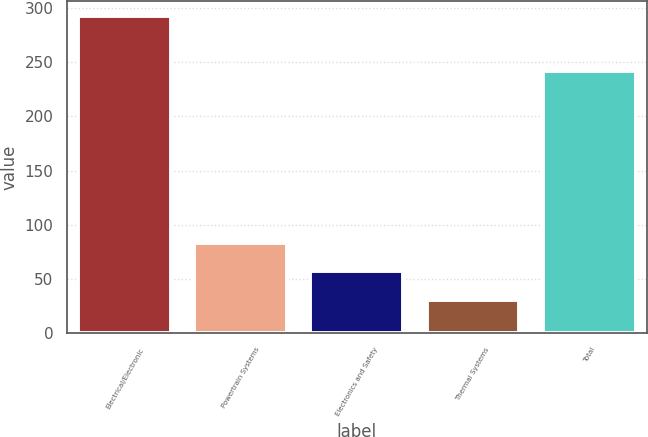Convert chart to OTSL. <chart><loc_0><loc_0><loc_500><loc_500><bar_chart><fcel>Electrical/Electronic<fcel>Powertrain Systems<fcel>Electronics and Safety<fcel>Thermal Systems<fcel>Total<nl><fcel>292<fcel>83.2<fcel>57.1<fcel>31<fcel>242<nl></chart> 